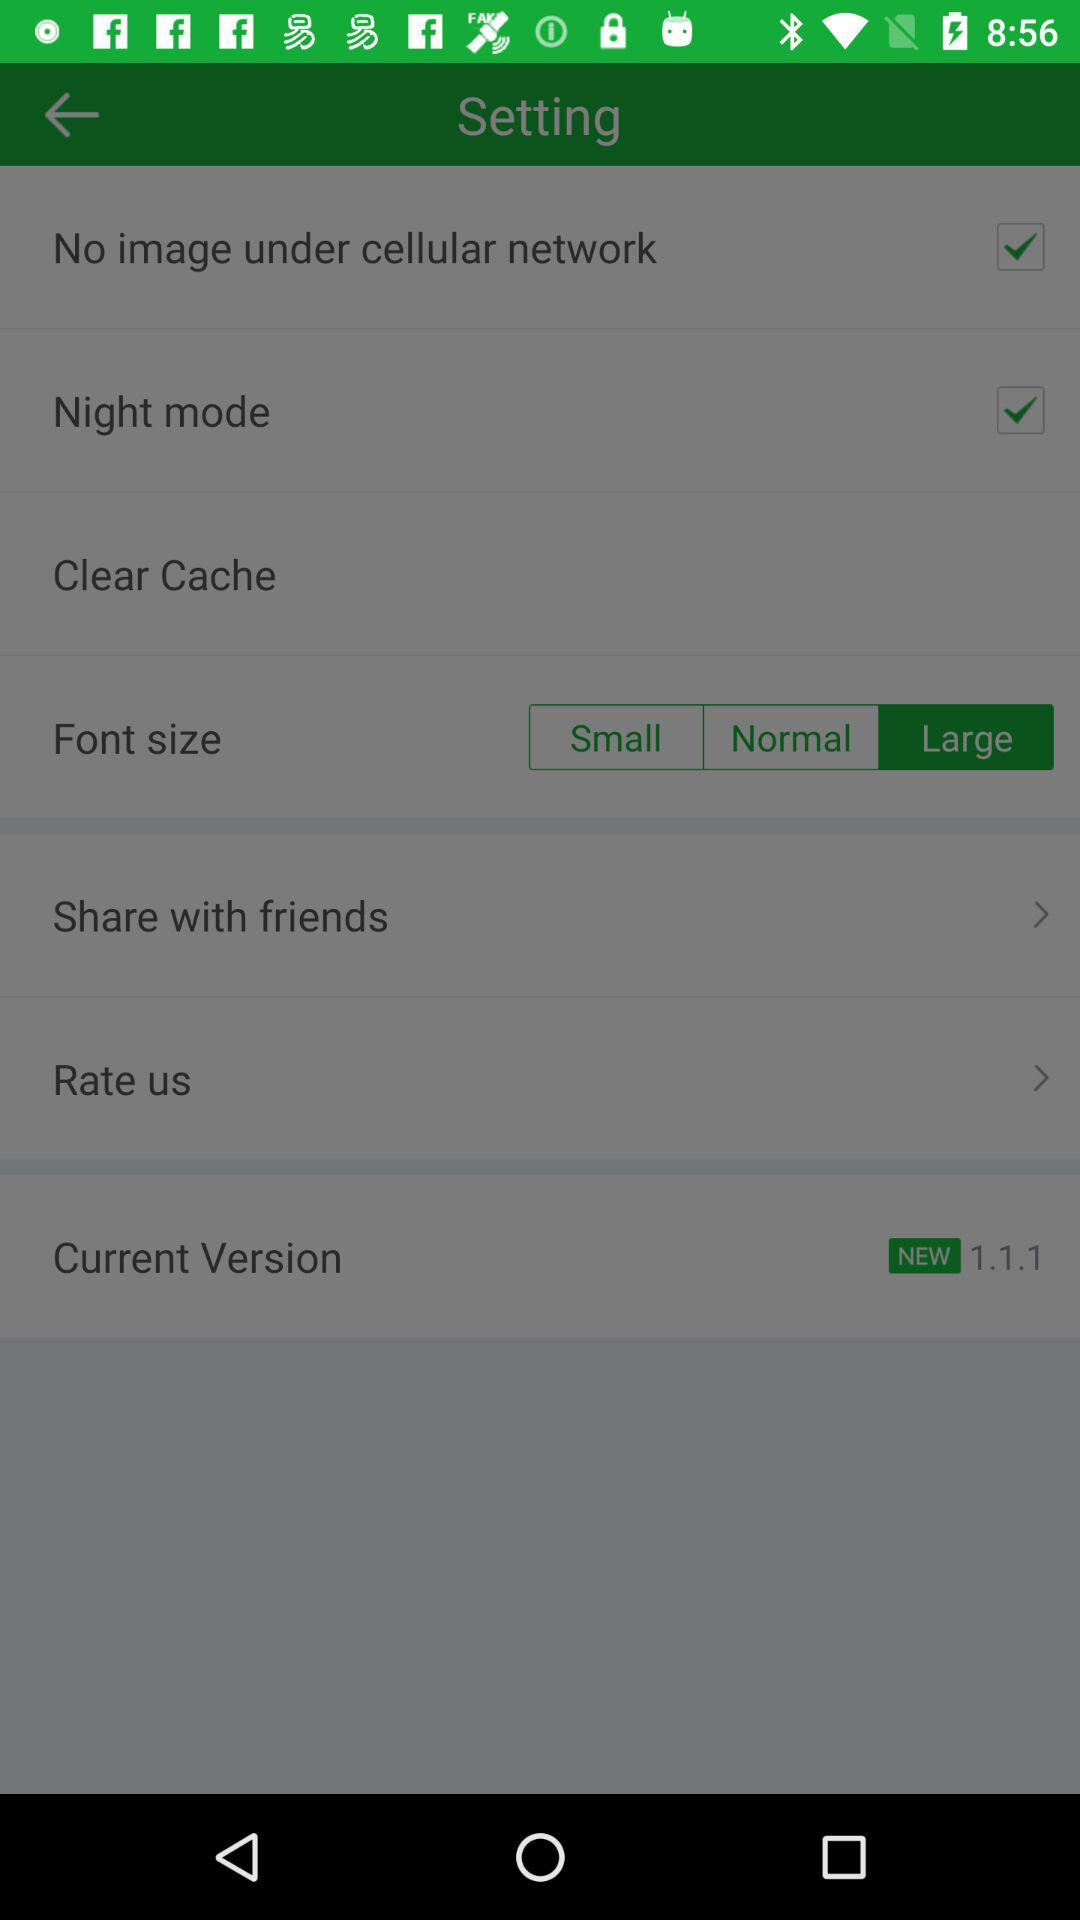What's the current version number? The current version number is 1.1.1. 